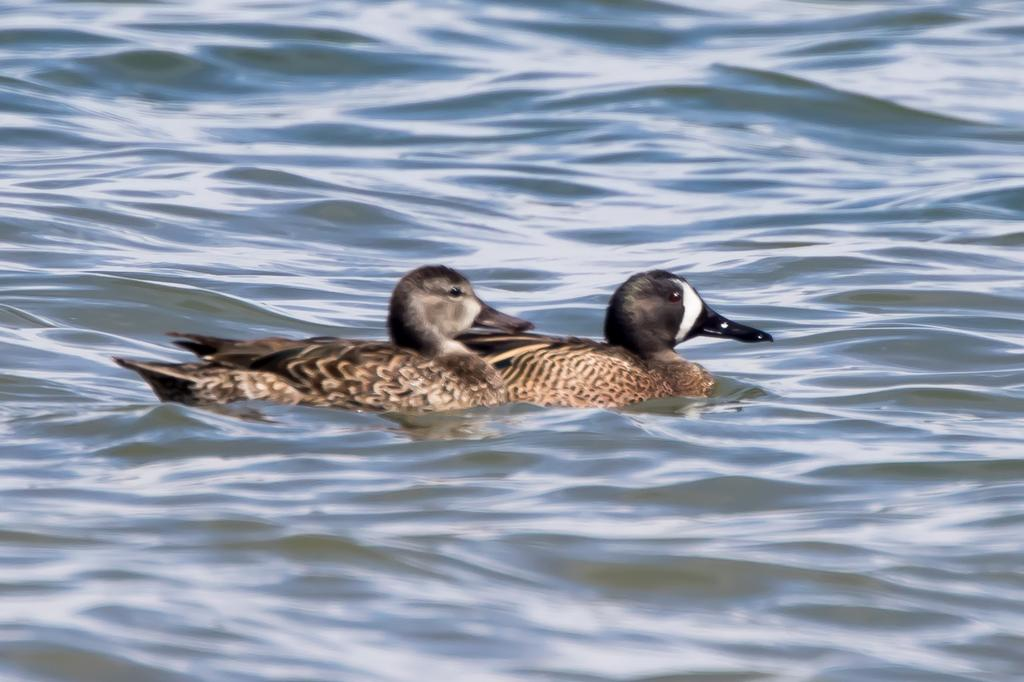How many ducks are in the image? There are two ducks in the image. Where are the ducks located? The ducks are in the water. What type of sheet is the father using to make an offer to the ducks in the image? There is no father, sheet, or offer present in the image; it only features two ducks in the water. 